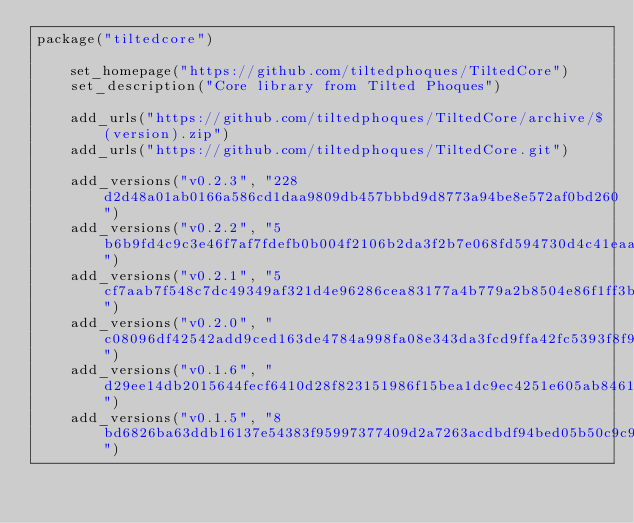<code> <loc_0><loc_0><loc_500><loc_500><_Lua_>package("tiltedcore")

    set_homepage("https://github.com/tiltedphoques/TiltedCore")
    set_description("Core library from Tilted Phoques")

    add_urls("https://github.com/tiltedphoques/TiltedCore/archive/$(version).zip")
    add_urls("https://github.com/tiltedphoques/TiltedCore.git")

    add_versions("v0.2.3", "228d2d48a01ab0166a586cd1daa9809db457bbbd9d8773a94be8e572af0bd260")
    add_versions("v0.2.2", "5b6b9fd4c9c3e46f7af7fdefb0b004f2106b2da3f2b7e068fd594730d4c41eaa")
    add_versions("v0.2.1", "5cf7aab7f548c7dc49349af321d4e96286cea83177a4b779a2b8504e86f1ff3b")
    add_versions("v0.2.0", "c08096df42542add9ced163de4784a998fa08e343da3fcd9ffa42fc5393f8f93")
    add_versions("v0.1.6", "d29ee14db2015644fecf6410d28f823151986f15bea1dc9ec4251e605ab8461b")
    add_versions("v0.1.5", "8bd6826ba63ddb16137e54383f95997377409d2a7263acdbdf94bed05b50c9c9")</code> 